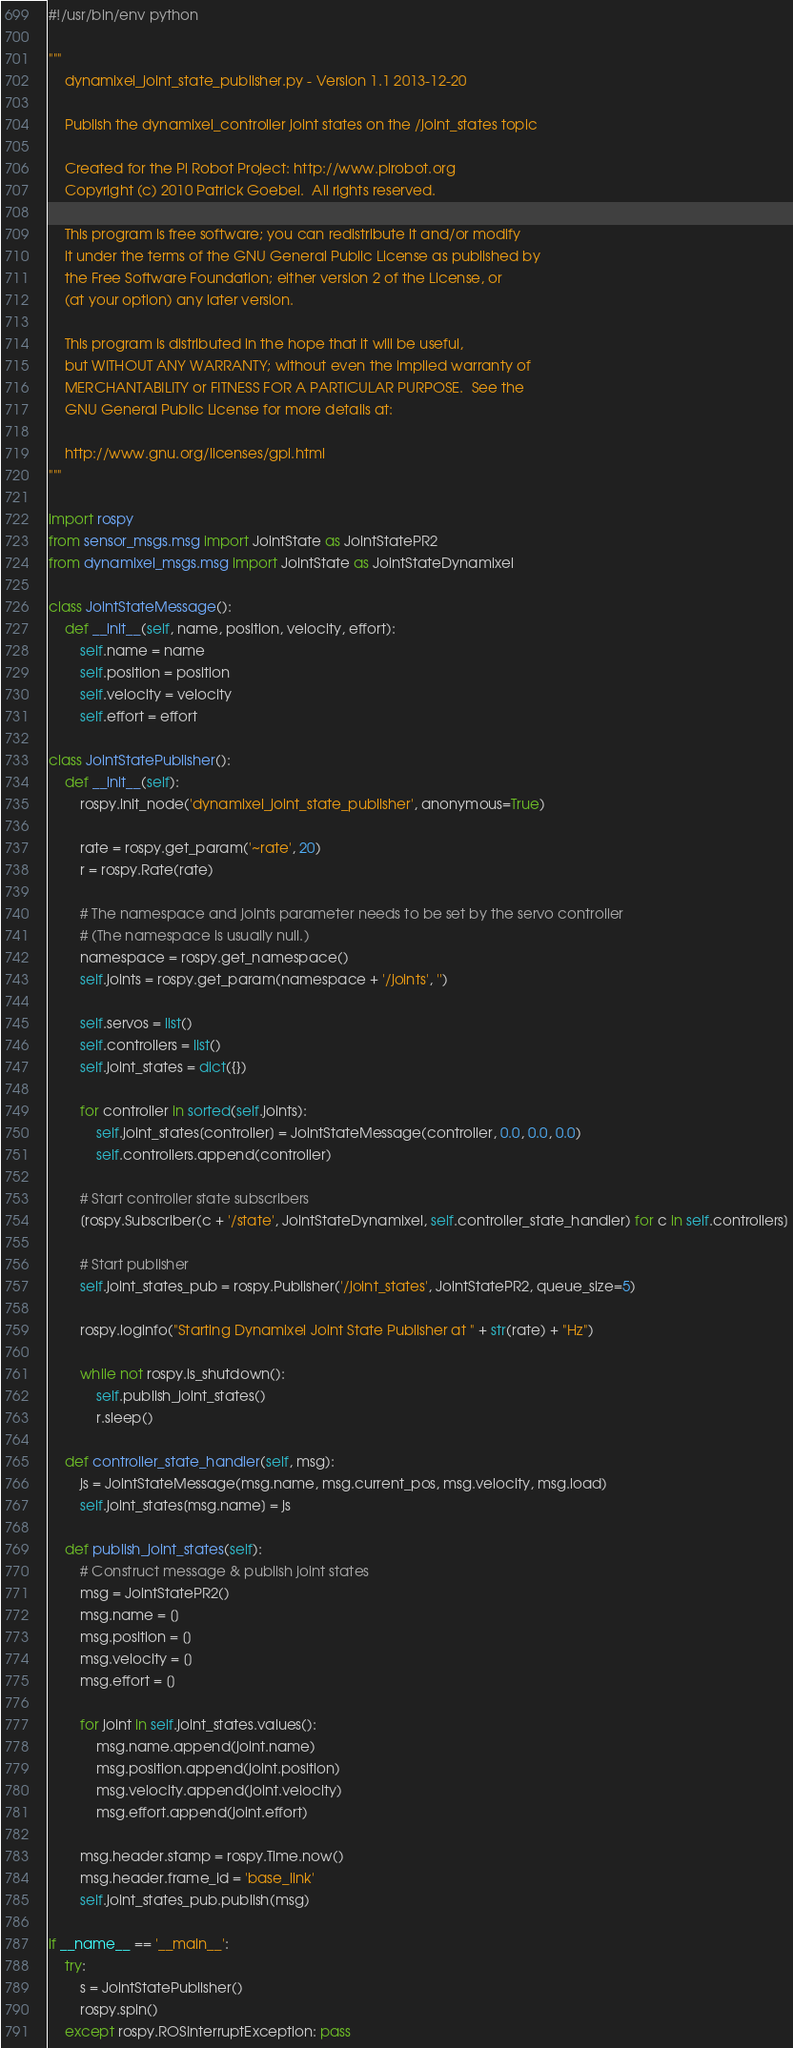Convert code to text. <code><loc_0><loc_0><loc_500><loc_500><_Python_>#!/usr/bin/env python

"""
    dynamixel_joint_state_publisher.py - Version 1.1 2013-12-20
    
    Publish the dynamixel_controller joint states on the /joint_states topic
    
    Created for the Pi Robot Project: http://www.pirobot.org
    Copyright (c) 2010 Patrick Goebel.  All rights reserved.

    This program is free software; you can redistribute it and/or modify
    it under the terms of the GNU General Public License as published by
    the Free Software Foundation; either version 2 of the License, or
    (at your option) any later version.
    
    This program is distributed in the hope that it will be useful,
    but WITHOUT ANY WARRANTY; without even the implied warranty of
    MERCHANTABILITY or FITNESS FOR A PARTICULAR PURPOSE.  See the
    GNU General Public License for more details at:
    
    http://www.gnu.org/licenses/gpl.html
"""

import rospy
from sensor_msgs.msg import JointState as JointStatePR2
from dynamixel_msgs.msg import JointState as JointStateDynamixel

class JointStateMessage():
    def __init__(self, name, position, velocity, effort):
        self.name = name
        self.position = position
        self.velocity = velocity
        self.effort = effort

class JointStatePublisher():
    def __init__(self):
        rospy.init_node('dynamixel_joint_state_publisher', anonymous=True)
        
        rate = rospy.get_param('~rate', 20)
        r = rospy.Rate(rate)
        
        # The namespace and joints parameter needs to be set by the servo controller
        # (The namespace is usually null.)
        namespace = rospy.get_namespace()
        self.joints = rospy.get_param(namespace + '/joints', '')
                                                                
        self.servos = list()
        self.controllers = list()
        self.joint_states = dict({})
        
        for controller in sorted(self.joints):
            self.joint_states[controller] = JointStateMessage(controller, 0.0, 0.0, 0.0)
            self.controllers.append(controller)
                           
        # Start controller state subscribers
        [rospy.Subscriber(c + '/state', JointStateDynamixel, self.controller_state_handler) for c in self.controllers]
     
        # Start publisher
        self.joint_states_pub = rospy.Publisher('/joint_states', JointStatePR2, queue_size=5)
       
        rospy.loginfo("Starting Dynamixel Joint State Publisher at " + str(rate) + "Hz")
       
        while not rospy.is_shutdown():
            self.publish_joint_states()
            r.sleep()
           
    def controller_state_handler(self, msg):
        js = JointStateMessage(msg.name, msg.current_pos, msg.velocity, msg.load)
        self.joint_states[msg.name] = js
       
    def publish_joint_states(self):
        # Construct message & publish joint states
        msg = JointStatePR2()
        msg.name = []
        msg.position = []
        msg.velocity = []
        msg.effort = []
       
        for joint in self.joint_states.values():
            msg.name.append(joint.name)
            msg.position.append(joint.position)
            msg.velocity.append(joint.velocity)
            msg.effort.append(joint.effort)
           
        msg.header.stamp = rospy.Time.now()
        msg.header.frame_id = 'base_link'
        self.joint_states_pub.publish(msg)
        
if __name__ == '__main__':
    try:
        s = JointStatePublisher()
        rospy.spin()
    except rospy.ROSInterruptException: pass

</code> 